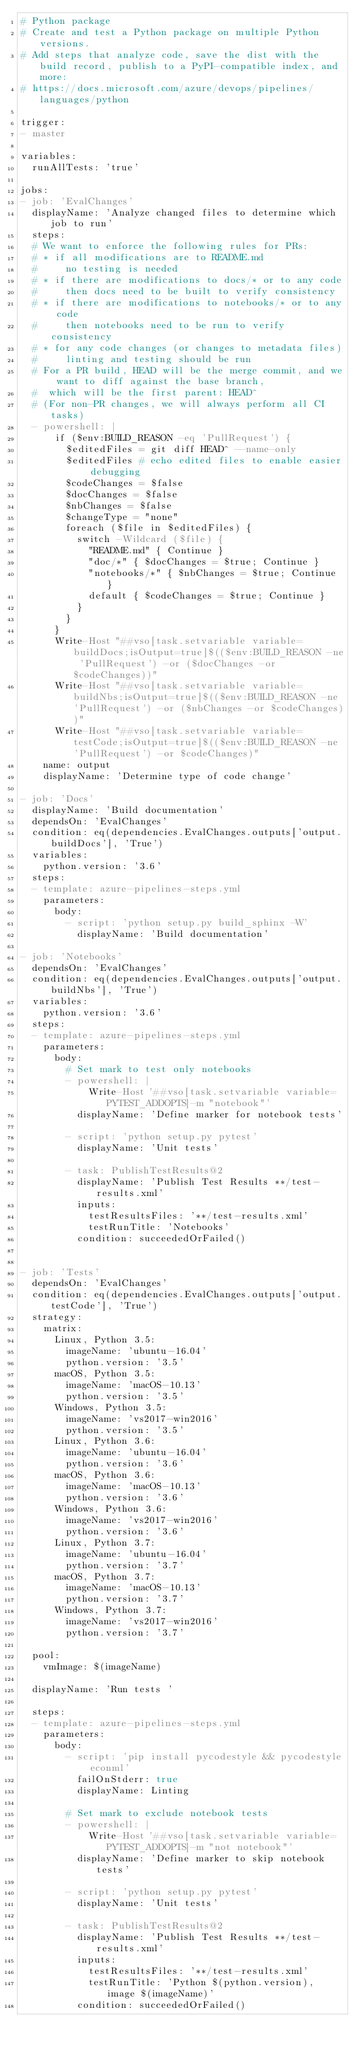<code> <loc_0><loc_0><loc_500><loc_500><_YAML_># Python package
# Create and test a Python package on multiple Python versions.
# Add steps that analyze code, save the dist with the build record, publish to a PyPI-compatible index, and more:
# https://docs.microsoft.com/azure/devops/pipelines/languages/python

trigger:
- master

variables:
  runAllTests: 'true'

jobs:
- job: 'EvalChanges'
  displayName: 'Analyze changed files to determine which job to run'
  steps:
  # We want to enforce the following rules for PRs:
  # * if all modifications are to README.md
  #     no testing is needed
  # * if there are modifications to docs/* or to any code
  #     then docs need to be built to verify consistency
  # * if there are modifications to notebooks/* or to any code
  #     then notebooks need to be run to verify consistency
  # * for any code changes (or changes to metadata files)
  #     linting and testing should be run
  # For a PR build, HEAD will be the merge commit, and we want to diff against the base branch,
  #  which will be the first parent: HEAD^ 
  # (For non-PR changes, we will always perform all CI tasks)
  - powershell: |
      if ($env:BUILD_REASON -eq 'PullRequest') {
        $editedFiles = git diff HEAD^ --name-only
        $editedFiles # echo edited files to enable easier debugging
        $codeChanges = $false
        $docChanges = $false
        $nbChanges = $false
        $changeType = "none"
        foreach ($file in $editedFiles) {
          switch -Wildcard ($file) {
            "README.md" { Continue }
            "doc/*" { $docChanges = $true; Continue }
            "notebooks/*" { $nbChanges = $true; Continue }
            default { $codeChanges = $true; Continue }
          }
        }
      }
      Write-Host "##vso[task.setvariable variable=buildDocs;isOutput=true]$(($env:BUILD_REASON -ne 'PullRequest') -or ($docChanges -or $codeChanges))"
      Write-Host "##vso[task.setvariable variable=buildNbs;isOutput=true]$(($env:BUILD_REASON -ne 'PullRequest') -or ($nbChanges -or $codeChanges))"
      Write-Host "##vso[task.setvariable variable=testCode;isOutput=true]$(($env:BUILD_REASON -ne 'PullRequest') -or $codeChanges)"
    name: output
    displayName: 'Determine type of code change'

- job: 'Docs'
  displayName: 'Build documentation'  
  dependsOn: 'EvalChanges'
  condition: eq(dependencies.EvalChanges.outputs['output.buildDocs'], 'True')
  variables:
    python.version: '3.6'
  steps:
  - template: azure-pipelines-steps.yml
    parameters:
      body:
        - script: 'python setup.py build_sphinx -W'
          displayName: 'Build documentation'

- job: 'Notebooks'
  dependsOn: 'EvalChanges'
  condition: eq(dependencies.EvalChanges.outputs['output.buildNbs'], 'True')
  variables:
    python.version: '3.6'
  steps:
  - template: azure-pipelines-steps.yml
    parameters:
      body:
        # Set mark to test only notebooks
        - powershell: |
            Write-Host '##vso[task.setvariable variable=PYTEST_ADDOPTS]-m "notebook"'
          displayName: 'Define marker for notebook tests'

        - script: 'python setup.py pytest'
          displayName: 'Unit tests'

        - task: PublishTestResults@2
          displayName: 'Publish Test Results **/test-results.xml'
          inputs:
            testResultsFiles: '**/test-results.xml'
            testRunTitle: 'Notebooks'
          condition: succeededOrFailed()


- job: 'Tests'
  dependsOn: 'EvalChanges'
  condition: eq(dependencies.EvalChanges.outputs['output.testCode'], 'True')
  strategy:
    matrix:
      Linux, Python 3.5:
        imageName: 'ubuntu-16.04'
        python.version: '3.5'
      macOS, Python 3.5:
        imageName: 'macOS-10.13'
        python.version: '3.5'
      Windows, Python 3.5:
        imageName: 'vs2017-win2016'
        python.version: '3.5'
      Linux, Python 3.6:
        imageName: 'ubuntu-16.04'
        python.version: '3.6'
      macOS, Python 3.6:
        imageName: 'macOS-10.13'
        python.version: '3.6'
      Windows, Python 3.6:
        imageName: 'vs2017-win2016'
        python.version: '3.6'
      Linux, Python 3.7:
        imageName: 'ubuntu-16.04'
        python.version: '3.7'
      macOS, Python 3.7:
        imageName: 'macOS-10.13'
        python.version: '3.7'
      Windows, Python 3.7:
        imageName: 'vs2017-win2016'
        python.version: '3.7'

  pool:
    vmImage: $(imageName)

  displayName: 'Run tests '

  steps:
  - template: azure-pipelines-steps.yml
    parameters:
      body:
        - script: 'pip install pycodestyle && pycodestyle econml'
          failOnStderr: true
          displayName: Linting

        # Set mark to exclude notebook tests
        - powershell: |
            Write-Host '##vso[task.setvariable variable=PYTEST_ADDOPTS]-m "not notebook"'
          displayName: 'Define marker to skip notebook tests'

        - script: 'python setup.py pytest'
          displayName: 'Unit tests'

        - task: PublishTestResults@2
          displayName: 'Publish Test Results **/test-results.xml'
          inputs:
            testResultsFiles: '**/test-results.xml'
            testRunTitle: 'Python $(python.version), image $(imageName)'
          condition: succeededOrFailed()
</code> 